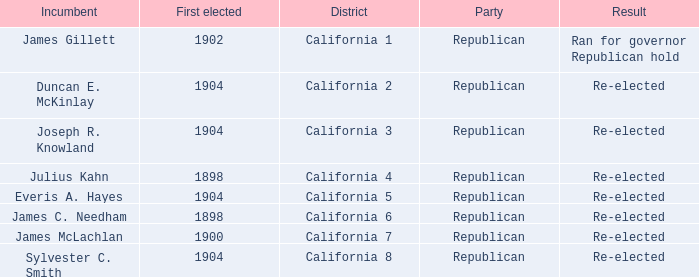Which Incumbent has a District of California 8? Sylvester C. Smith. 